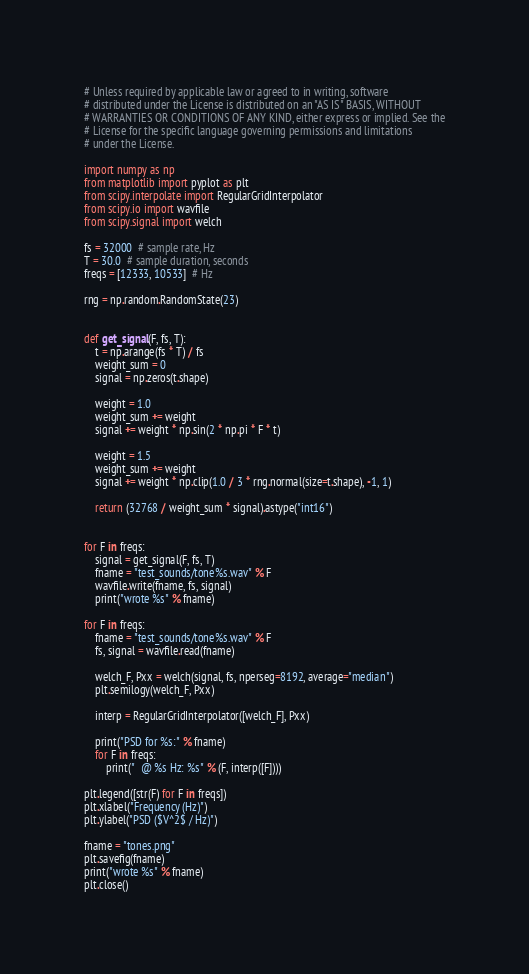<code> <loc_0><loc_0><loc_500><loc_500><_Python_># Unless required by applicable law or agreed to in writing, software
# distributed under the License is distributed on an "AS IS" BASIS, WITHOUT
# WARRANTIES OR CONDITIONS OF ANY KIND, either express or implied. See the
# License for the specific language governing permissions and limitations
# under the License.

import numpy as np
from matplotlib import pyplot as plt
from scipy.interpolate import RegularGridInterpolator
from scipy.io import wavfile
from scipy.signal import welch

fs = 32000  # sample rate, Hz
T = 30.0  # sample duration, seconds
freqs = [12333, 10533]  # Hz

rng = np.random.RandomState(23)


def get_signal(F, fs, T):
    t = np.arange(fs * T) / fs
    weight_sum = 0
    signal = np.zeros(t.shape)

    weight = 1.0
    weight_sum += weight
    signal += weight * np.sin(2 * np.pi * F * t)

    weight = 1.5
    weight_sum += weight
    signal += weight * np.clip(1.0 / 3 * rng.normal(size=t.shape), -1, 1)

    return (32768 / weight_sum * signal).astype("int16")


for F in freqs:
    signal = get_signal(F, fs, T)
    fname = "test_sounds/tone%s.wav" % F
    wavfile.write(fname, fs, signal)
    print("wrote %s" % fname)

for F in freqs:
    fname = "test_sounds/tone%s.wav" % F
    fs, signal = wavfile.read(fname)

    welch_F, Pxx = welch(signal, fs, nperseg=8192, average="median")
    plt.semilogy(welch_F, Pxx)

    interp = RegularGridInterpolator([welch_F], Pxx)

    print("PSD for %s:" % fname)
    for F in freqs:
        print("  @ %s Hz: %s" % (F, interp([F])))

plt.legend([str(F) for F in freqs])
plt.xlabel("Frequency (Hz)")
plt.ylabel("PSD ($V^2$ / Hz)")

fname = "tones.png"
plt.savefig(fname)
print("wrote %s" % fname)
plt.close()
</code> 